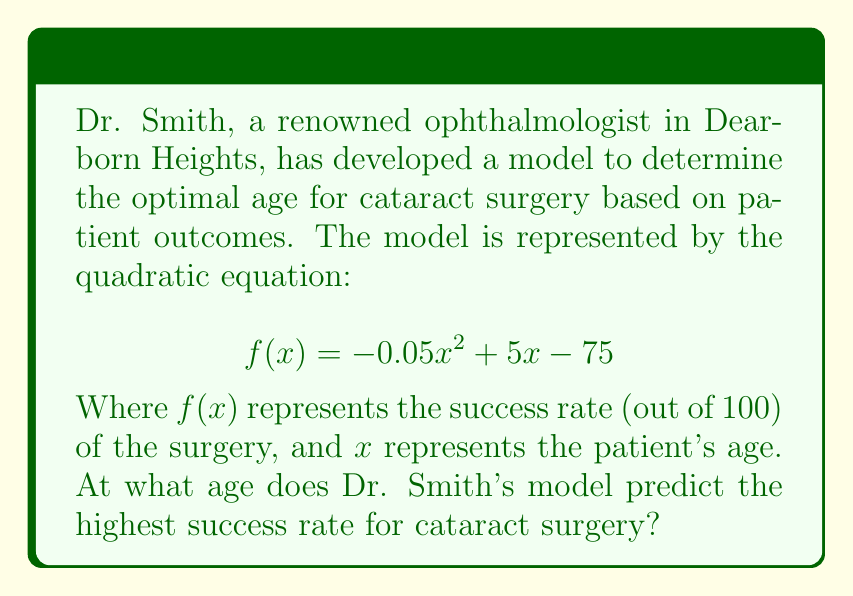Can you solve this math problem? To find the optimal age for cataract surgery according to Dr. Smith's model, we need to determine the vertex of the parabola represented by the given quadratic equation. The vertex represents the maximum point of the parabola, which corresponds to the age with the highest success rate.

For a quadratic equation in the form $f(x) = ax^2 + bx + c$, the x-coordinate of the vertex is given by $x = -\frac{b}{2a}$.

In this case:
$a = -0.05$
$b = 5$
$c = -75$

Let's calculate the x-coordinate of the vertex:

$$ x = -\frac{b}{2a} = -\frac{5}{2(-0.05)} = \frac{5}{0.1} = 50 $$

To verify this result and find the maximum success rate, we can substitute $x = 50$ into the original equation:

$$ f(50) = -0.05(50)^2 + 5(50) - 75 $$
$$ = -0.05(2500) + 250 - 75 $$
$$ = -125 + 250 - 75 $$
$$ = 50 $$

This confirms that the maximum success rate is 50% and occurs at age 50.
Answer: The optimal age for cataract surgery, according to Dr. Smith's model, is 50 years old. 